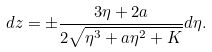Convert formula to latex. <formula><loc_0><loc_0><loc_500><loc_500>d z = \pm \frac { 3 \eta + 2 a } { 2 \sqrt { \eta ^ { 3 } + a \eta ^ { 2 } + K } } d \eta .</formula> 